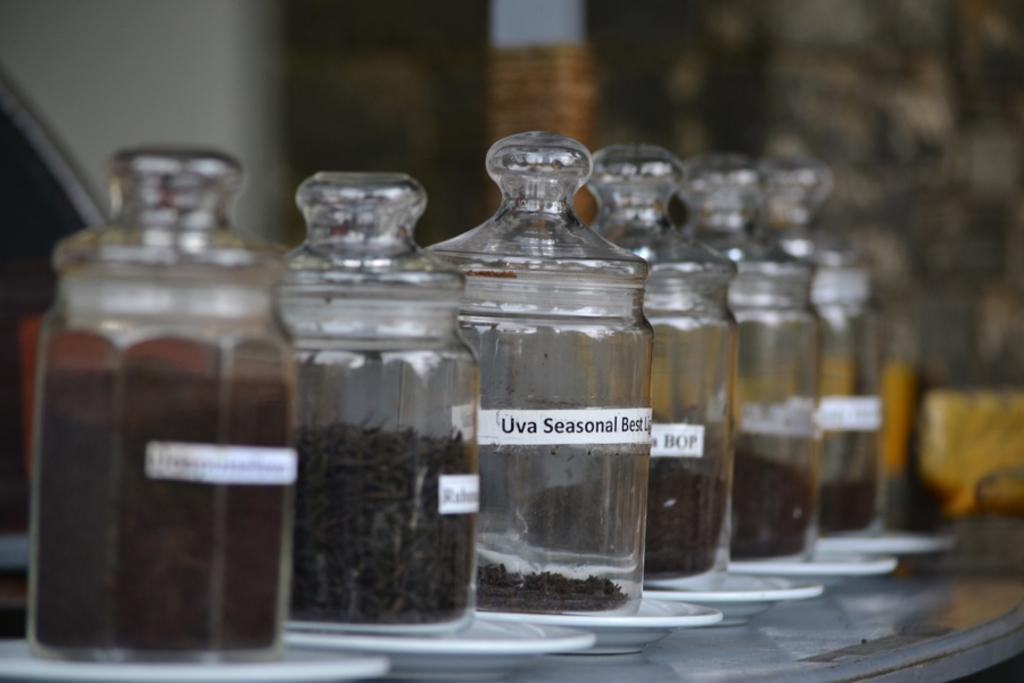<image>
Relay a brief, clear account of the picture shown. A row of glass containers with one label stating Uva Seasonal 